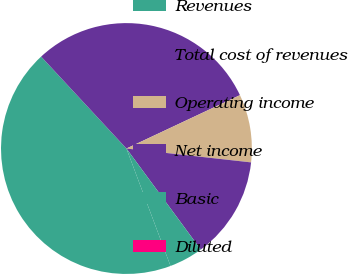Convert chart to OTSL. <chart><loc_0><loc_0><loc_500><loc_500><pie_chart><fcel>Revenues<fcel>Total cost of revenues<fcel>Operating income<fcel>Net income<fcel>Basic<fcel>Diluted<nl><fcel>43.81%<fcel>29.91%<fcel>8.76%<fcel>13.14%<fcel>4.38%<fcel>0.0%<nl></chart> 